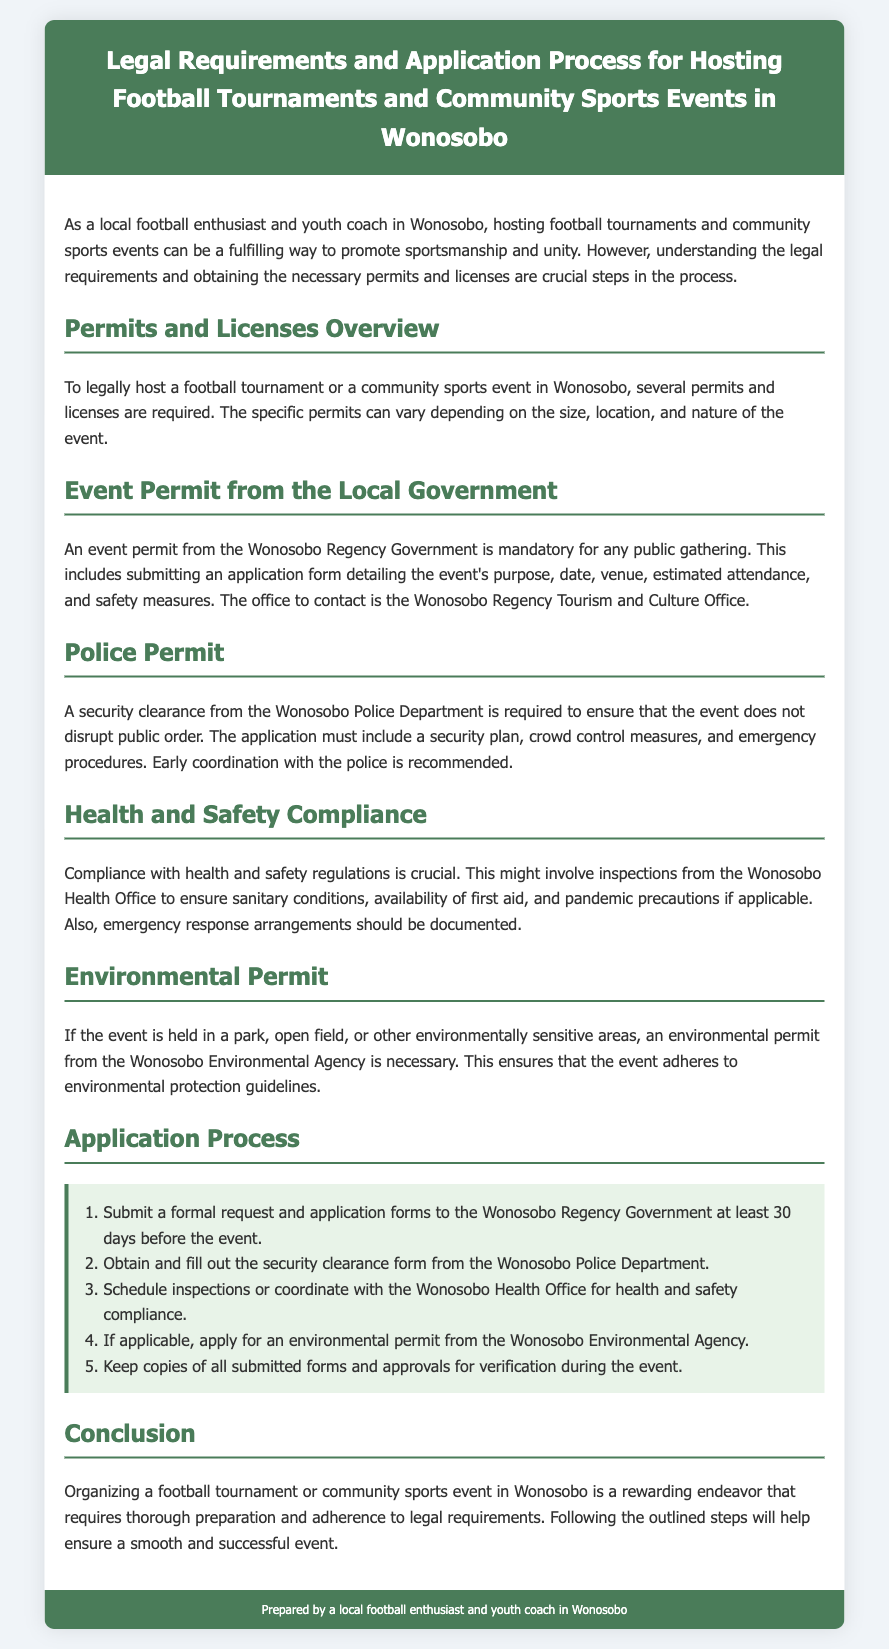What is the mandatory permit for public gatherings? The document states that an event permit from the Wonosobo Regency Government is mandatory for any public gathering.
Answer: Event permit Which office should be contacted for the event permit? The document indicates that the office to contact for the event permit is the Wonosobo Regency Tourism and Culture Office.
Answer: Wonosobo Regency Tourism and Culture Office How many days in advance must applications be submitted? The document specifies that formal requests and application forms should be submitted at least 30 days before the event.
Answer: 30 days What type of plan is required for the police permit? According to the document, the application for a police permit must include a security plan.
Answer: Security plan Which agency issues the environmental permit? The document notes that the environmental permit is issued by the Wonosobo Environmental Agency.
Answer: Wonosobo Environmental Agency What is a necessary health measure mentioned in the document? The document highlights that availability of first aid is a crucial health measure to comply with health regulations.
Answer: Availability of first aid Which department coordinates health and safety compliance? The document states that the Wonosobo Health Office is responsible for coordinating health and safety compliance.
Answer: Wonosobo Health Office What must be kept after submitting the forms? The document advises keeping copies of all submitted forms and approvals for verification during the event.
Answer: Copies of all submitted forms and approvals 